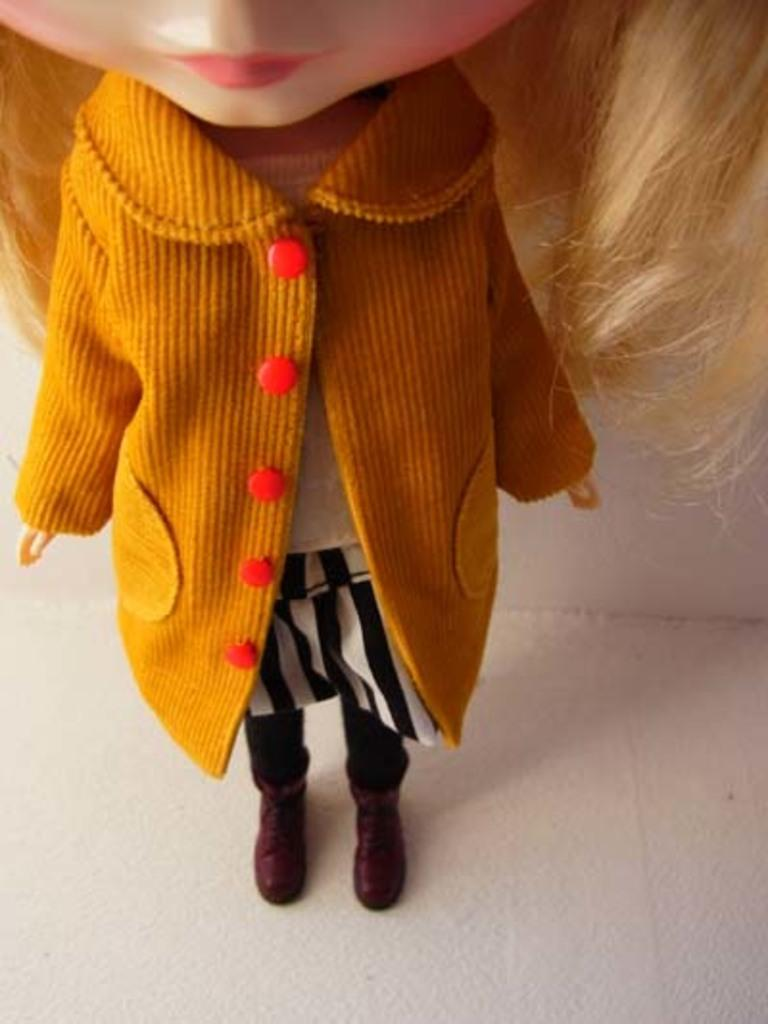What object can be seen in the image? There is a toy in the image. What color is the toy's jacket? The toy has a yellow color jacket. Where is the toy located in the image? The toy is kept on the floor. What type of bears can be seen participating in a competition in the wilderness in the image? There are no bears, competition, or wilderness present in the image; it features a toy with a yellow jacket on the floor. 